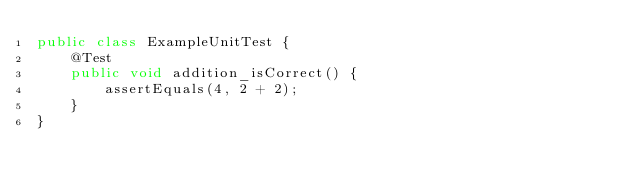<code> <loc_0><loc_0><loc_500><loc_500><_Java_>public class ExampleUnitTest {
    @Test
    public void addition_isCorrect() {
        assertEquals(4, 2 + 2);
    }
}</code> 